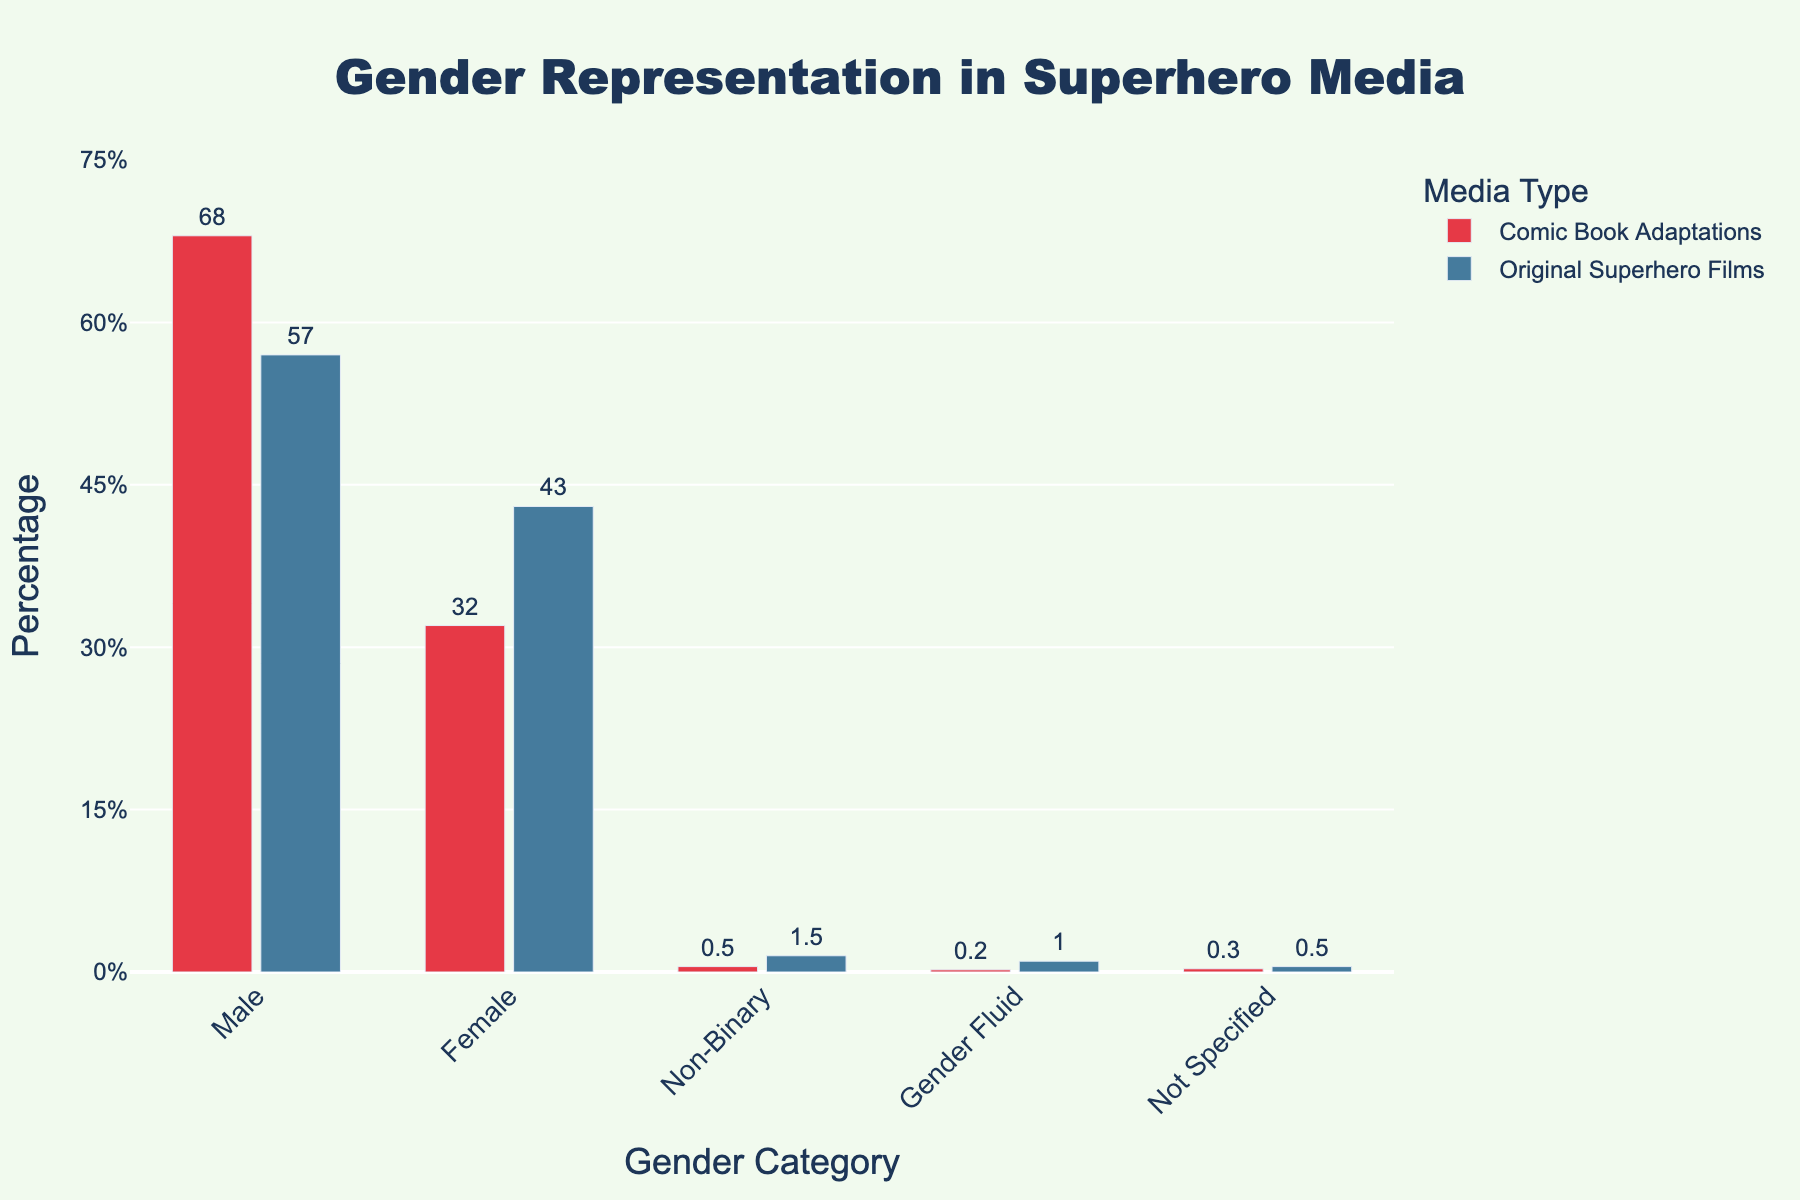What is the difference in percentage of male characters between comic book adaptations and original superhero films? The percentage of male characters in comic book adaptations is 68% and in original superhero films is 57%. The difference is calculated as 68% - 57% = 11%.
Answer: 11% Which category has the largest percentage of characters in comic book adaptations? In comic book adaptations, the percentage values are: Male (68%), Female (32%), Non-Binary (0.5%), Gender Fluid (0.2%), Not Specified (0.3%). The largest value is in the Male category.
Answer: Male What is the combined percentage of non-binary and gender fluid characters in original superhero films? In original superhero films, the percentage of non-binary characters is 1.5% and gender fluid characters is 1%. Adding these gives 1.5% + 1% = 2.5%.
Answer: 2.5% How does the percentage of female characters in comic book adaptations compare to original superhero films? The percentage of female characters in comic book adaptations is 32% and in original superhero films is 43%. 43% is greater than 32%, indicating a higher representation in original films.
Answer: Higher in original superhero films Which media type has the highest representation of non-specified gender characters? The percentage of non-specified gender characters in comic book adaptations is 0.3% and in original superhero films is 0.5%. Comparing these, original superhero films have a higher representation of non-specified gender characters.
Answer: Original superhero films What is the average percentage of male characters across both media types? The percentage of male characters is 68% for comic book adaptations and 57% for original superhero films. The average is (68% + 57%) / 2 = 125% / 2 = 62.5%.
Answer: 62.5% If we sum all the percentages of gender fluid characters in both media types, what do we get? The percentage of gender fluid characters in comic book adaptations is 0.2% and in original superhero films is 1%. Summing these values, 0.2% + 1% = 1.2%.
Answer: 1.2% Do original superhero films have a greater or lesser percentage of female characters than any other category in both media types? The percentage of female characters in original superhero films is 43%. The other categories have the following percentages: Male (68%, 57%), Non-Binary (0.5%, 1.5%), Gender Fluid (0.2%, 1%), Not Specified (0.3%, 0.5%). 43% is greater than the percentages for all categories except for Male.
Answer: Greater than all except Male 